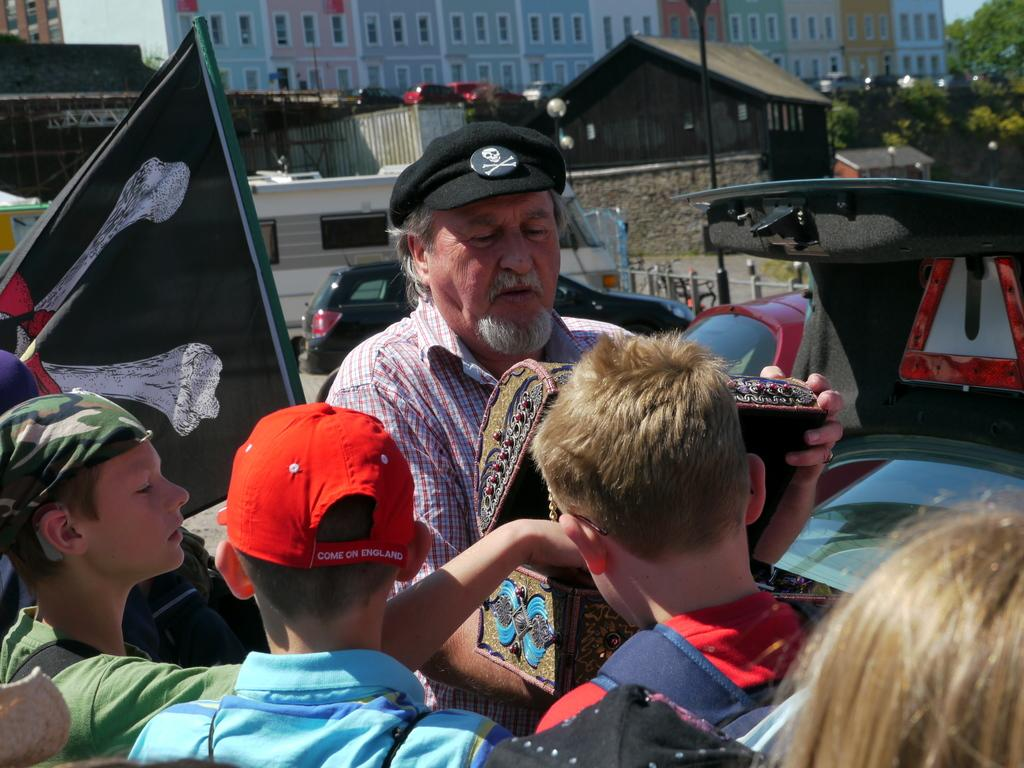What is the person in the image holding? The person is holding a box in the image. Who is in front of the person? There are kids in front of the person. What is located behind the person? There is a flag behind the person. What can be seen in the background of the image? Cars, lamp posts, buildings, and trees are present in the background of the image. What is the person's belief about the shape of the bat in the image? There is no bat present in the image, so it is not possible to determine the person's belief about its shape. 